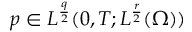<formula> <loc_0><loc_0><loc_500><loc_500>p \in L ^ { \frac { q } { 2 } } ( 0 , T ; L ^ { \frac { r } { 2 } } ( \Omega ) )</formula> 